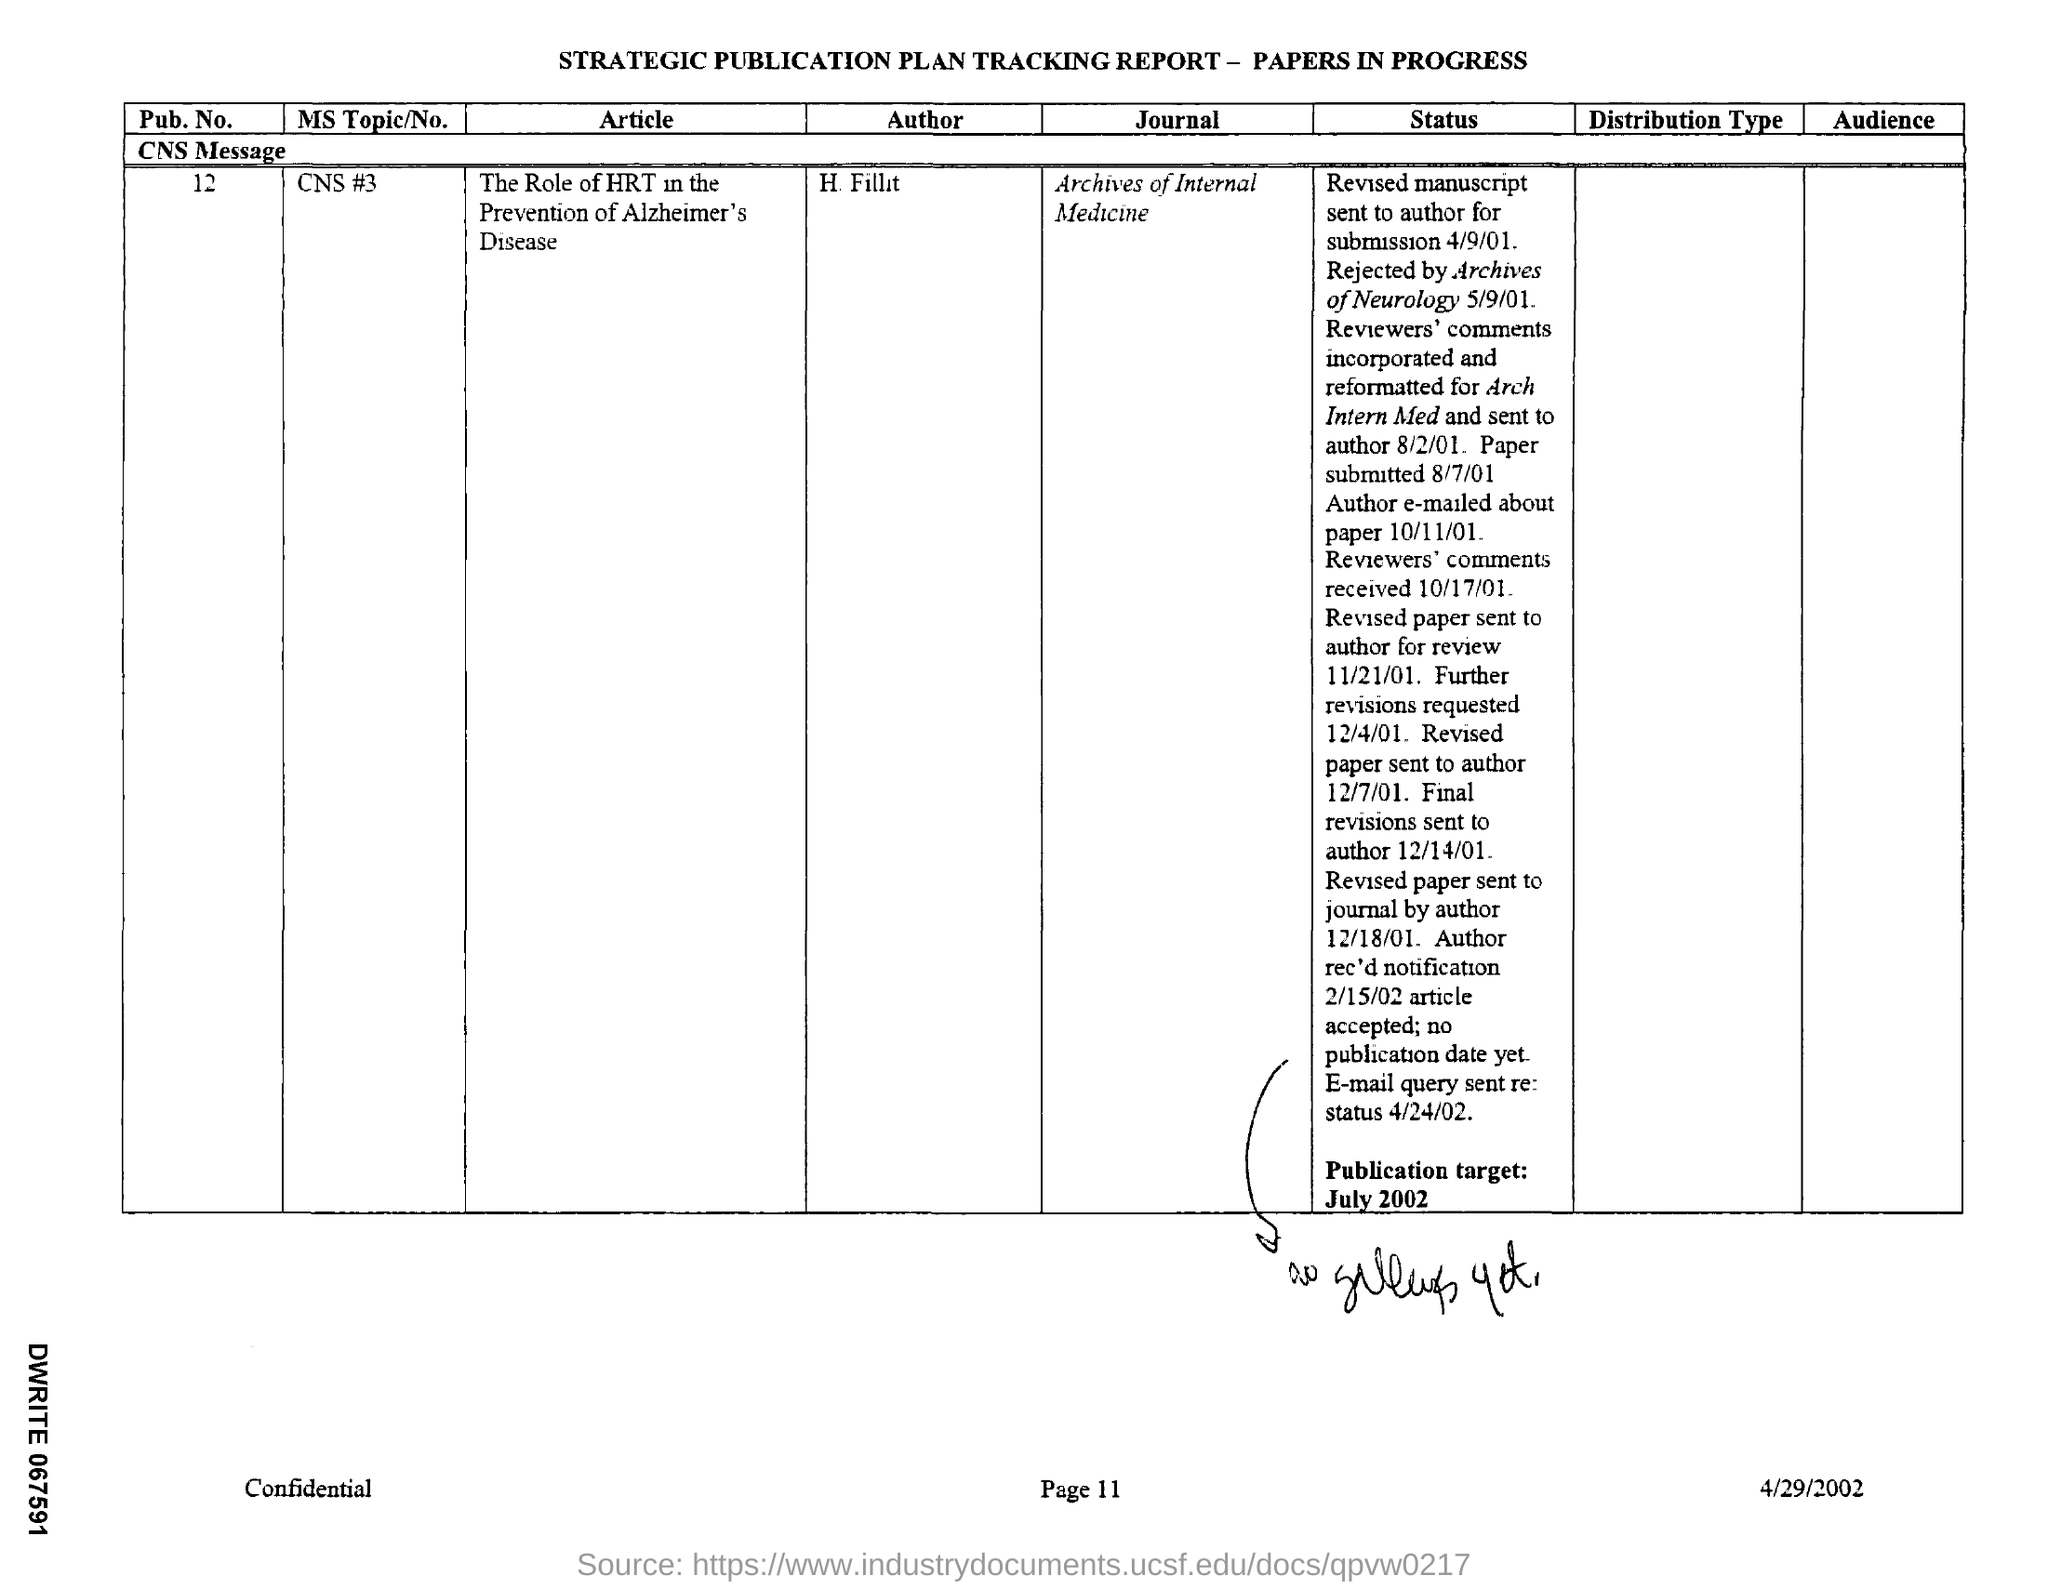Which is the Journal?
Offer a terse response. Archives of Internal Medicine. What is the date on the document?
Provide a succinct answer. 4/29/2002. 